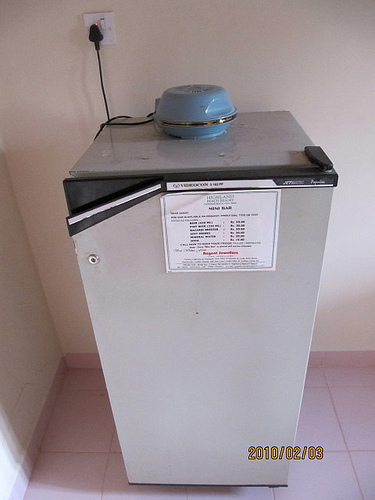Extract all visible text content from this image. 2010 02 03 